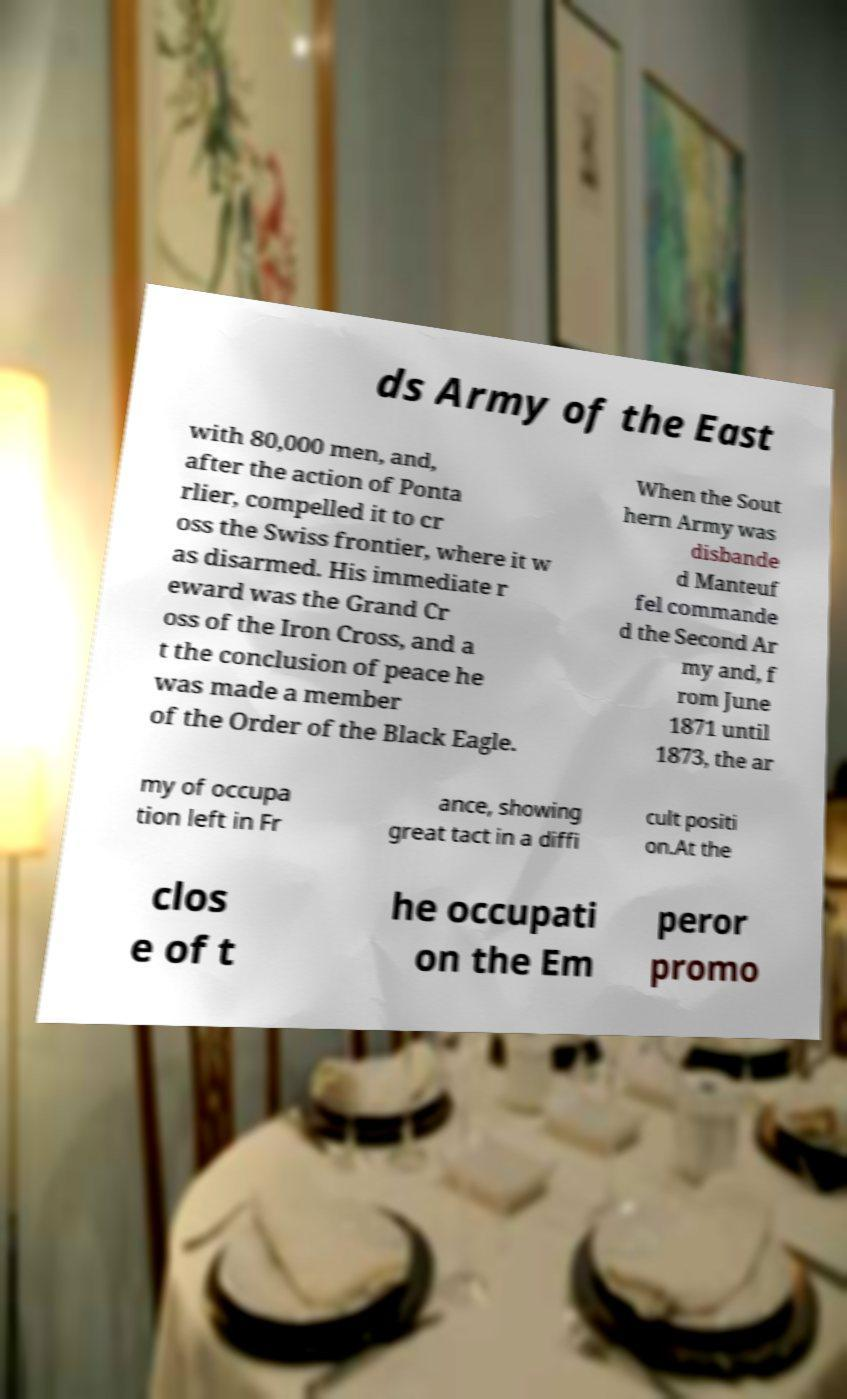Could you extract and type out the text from this image? ds Army of the East with 80,000 men, and, after the action of Ponta rlier, compelled it to cr oss the Swiss frontier, where it w as disarmed. His immediate r eward was the Grand Cr oss of the Iron Cross, and a t the conclusion of peace he was made a member of the Order of the Black Eagle. When the Sout hern Army was disbande d Manteuf fel commande d the Second Ar my and, f rom June 1871 until 1873, the ar my of occupa tion left in Fr ance, showing great tact in a diffi cult positi on.At the clos e of t he occupati on the Em peror promo 